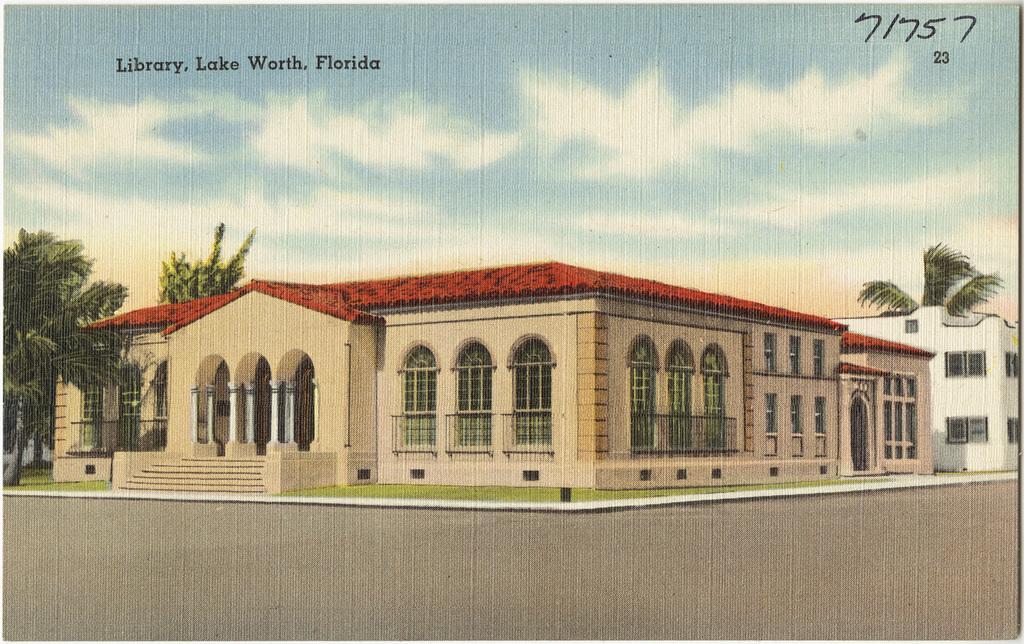Could you give a brief overview of what you see in this image? This is a picture of a poster, where there are buildings, trees, sky, numbers and words. 